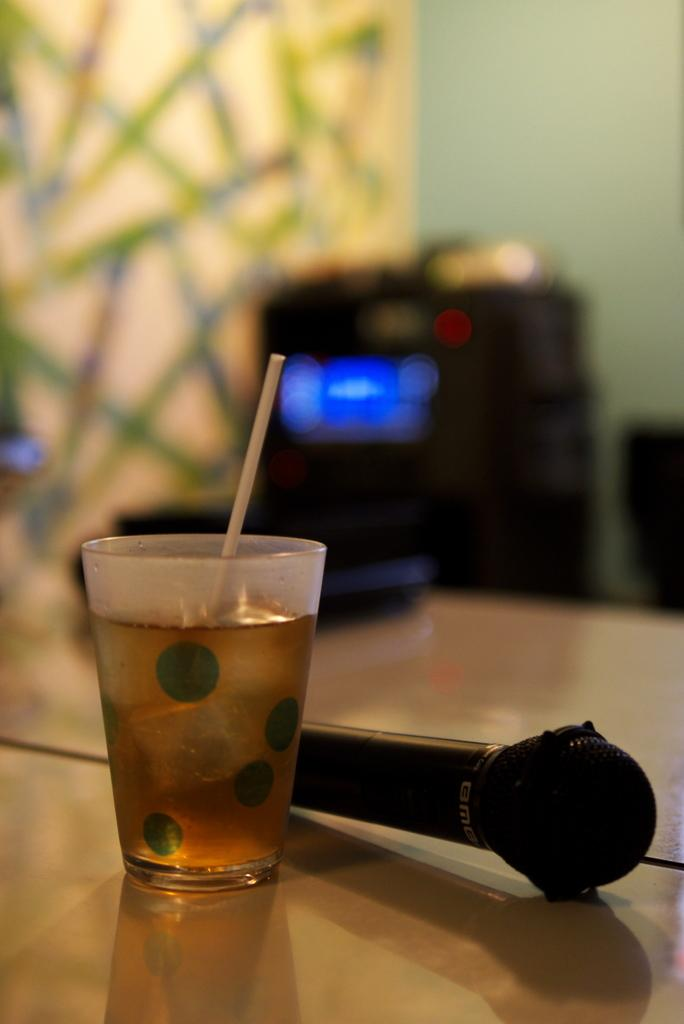What is in the glass that is visible in the image? The glass contains a drink. What other objects can be seen in the image? There is a microphone (mike) in the image. What type of mint is growing on the microphone in the image? There is no mint growing on the microphone in the image; it is not present. 